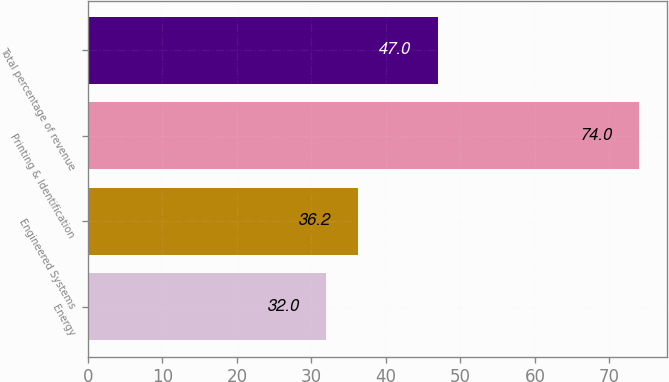Convert chart. <chart><loc_0><loc_0><loc_500><loc_500><bar_chart><fcel>Energy<fcel>Engineered Systems<fcel>Printing & Identification<fcel>Total percentage of revenue<nl><fcel>32<fcel>36.2<fcel>74<fcel>47<nl></chart> 